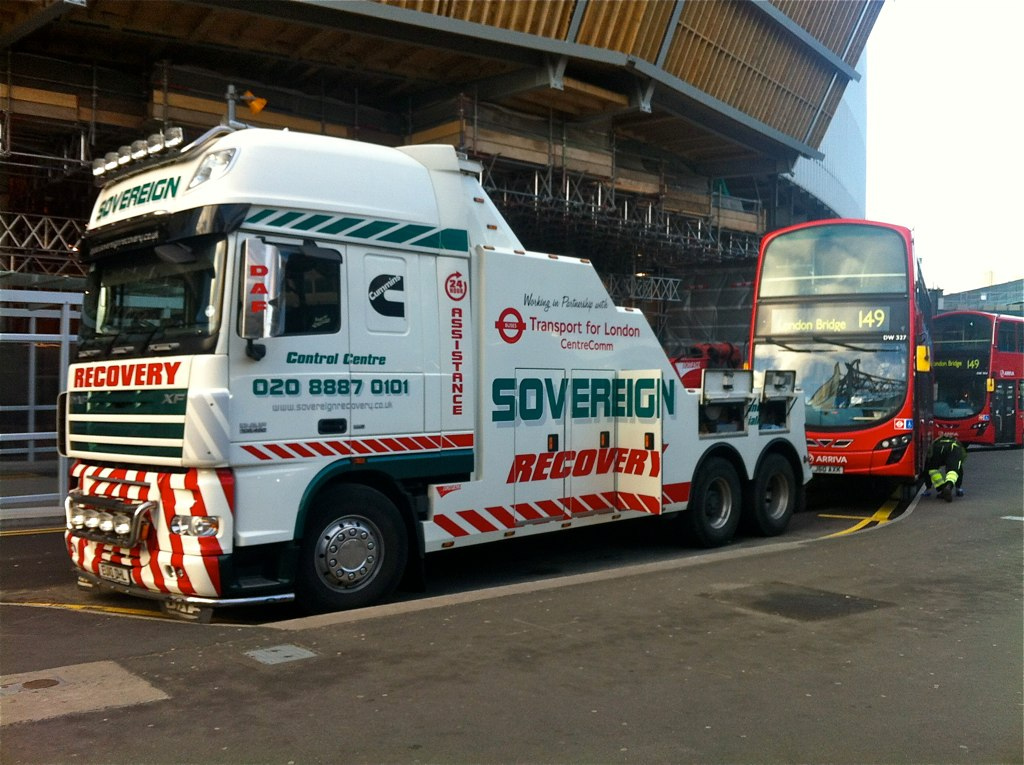What safety measures should be taken during a recovery operation? During a recovery operation, safety measures should include using hazard lights and the deployment of traffic cones or signs to alert oncoming vehicles. The recovery personnel should wear high-visibility clothing and ensure the area is secure before proceeding with recovery tasks. 